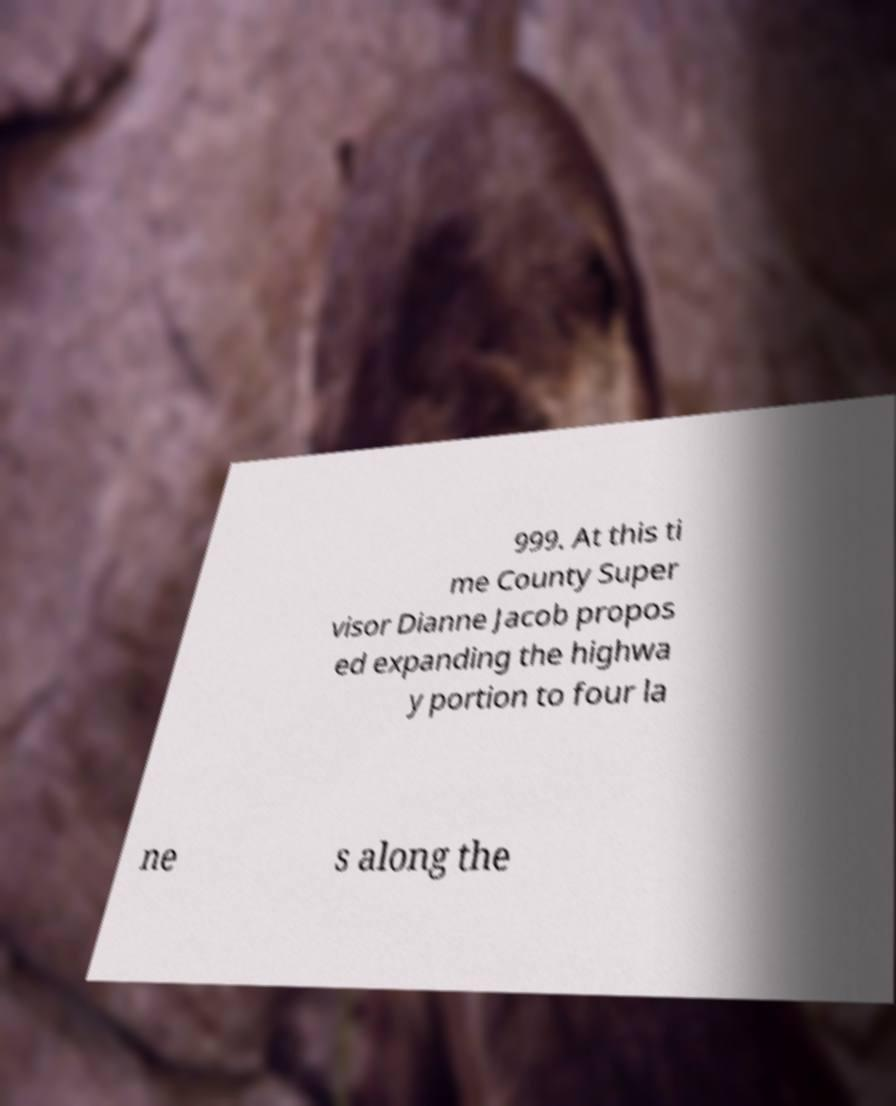What messages or text are displayed in this image? I need them in a readable, typed format. 999. At this ti me County Super visor Dianne Jacob propos ed expanding the highwa y portion to four la ne s along the 